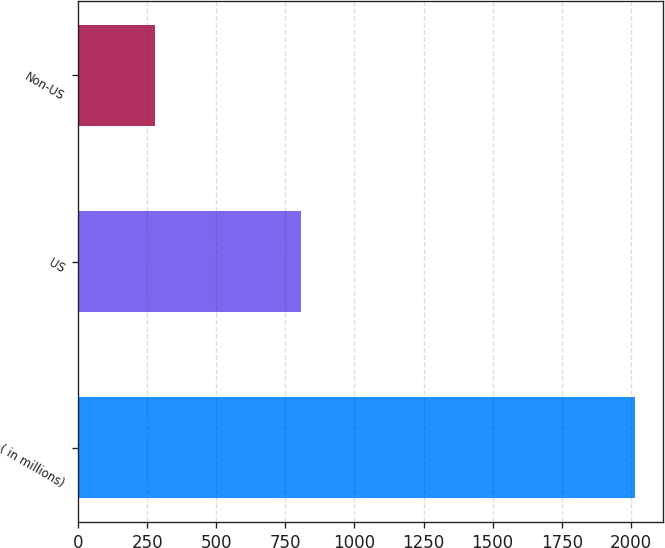<chart> <loc_0><loc_0><loc_500><loc_500><bar_chart><fcel>( in millions)<fcel>US<fcel>Non-US<nl><fcel>2014<fcel>808<fcel>280<nl></chart> 